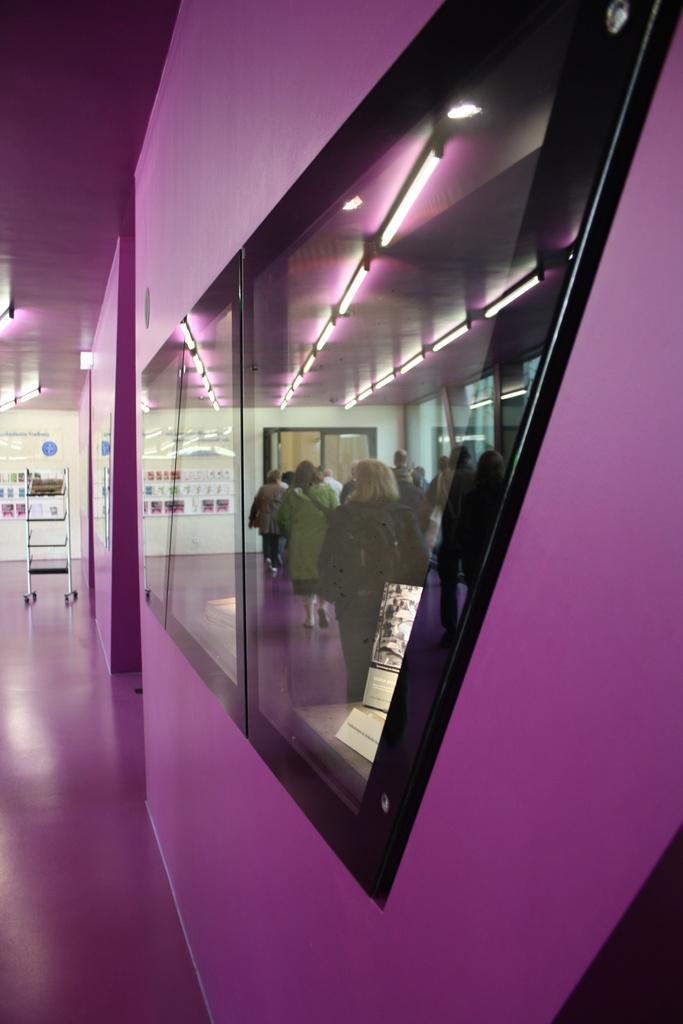Could you give a brief overview of what you see in this image? In this image we can see a wall and glass objects. Through the glass objects we can see some reflections. In the background of the image there is a wall, name boards and other objects. On the left side bottom of the image there is the floor. On the left side top of the image there is the ceiling. 